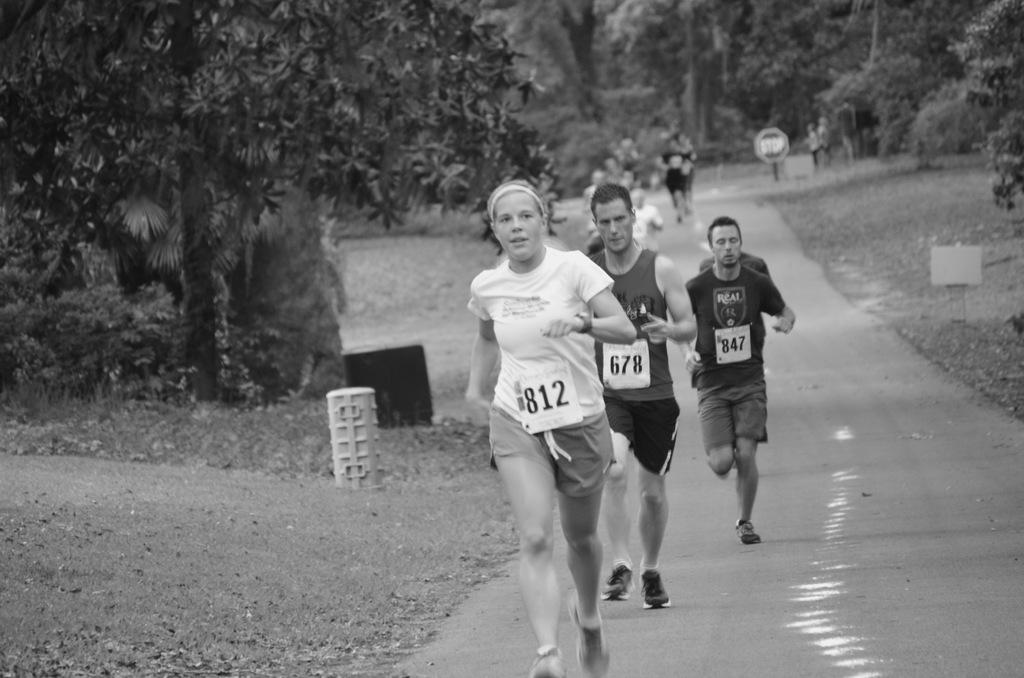How many people are in the image? There are people in the image, but the exact number is not specified. What are the people wearing? The people are wearing clothes and shoes. What are the people doing in the image? The people are running. What type of surface can be seen in the image? There is a road and grass in the image. What type of plant is visible in the image? There is a tree in the image. What objects can be seen in the image? There is an object and a board in the image. What type of bucket is being used by the spy to collect information in the image? There is no bucket or spy present in the image. What type of education is being provided to the people in the image? There is no indication of any educational activity in the image. 